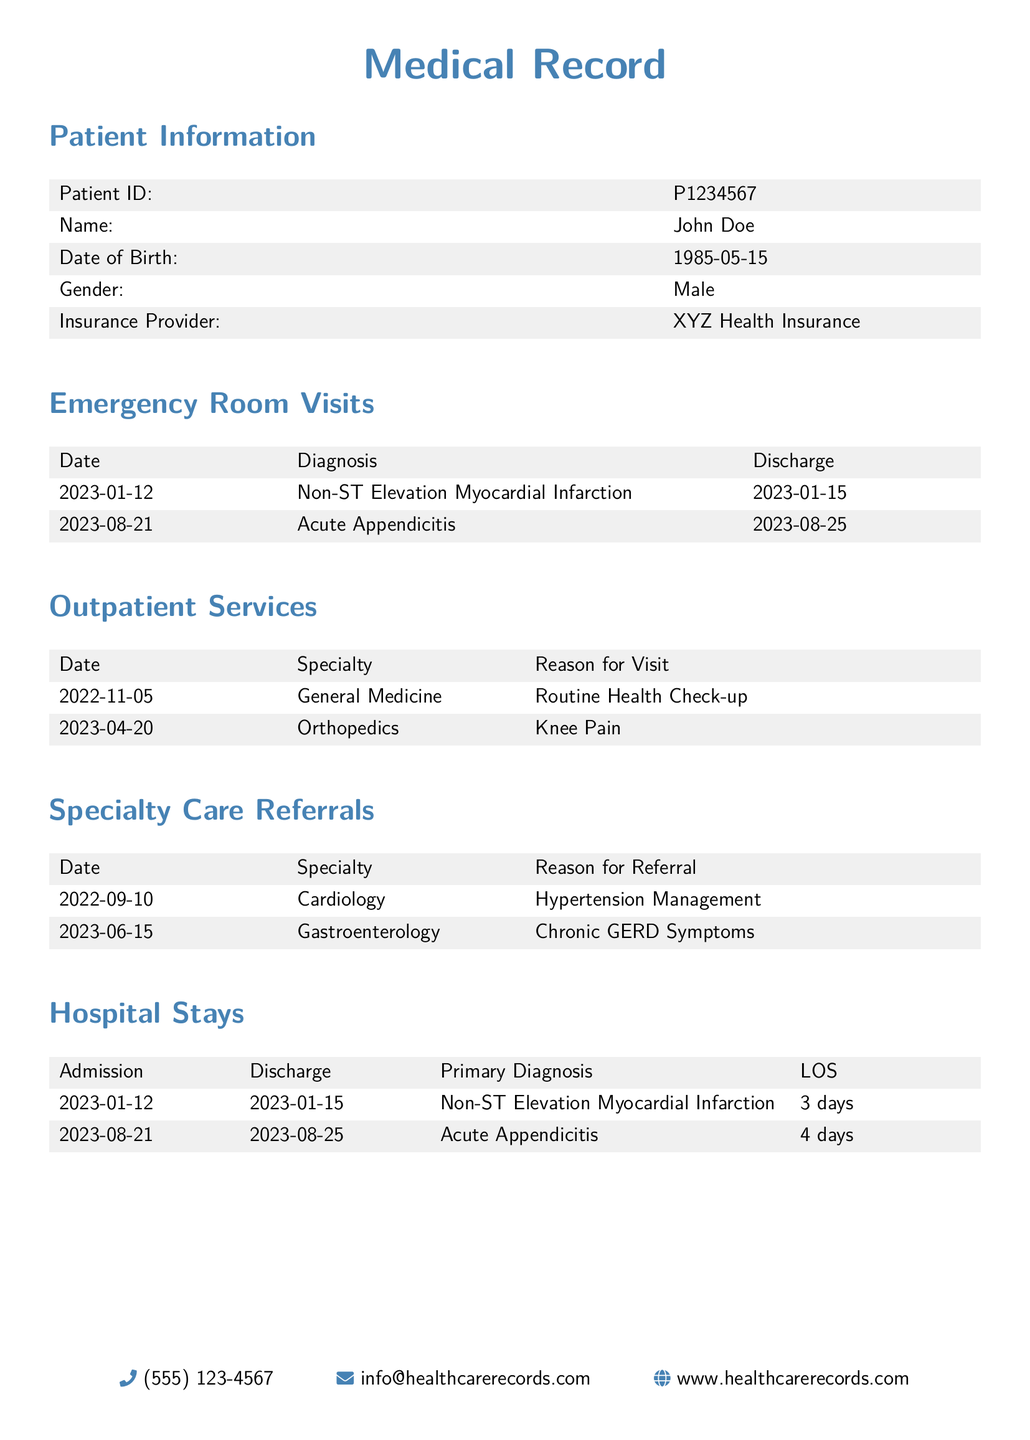What is the patient's name? The patient's name is listed in the Patient Information section of the document.
Answer: John Doe How many emergency room visits are recorded? The number of emergency room visits can be counted from the Emergency Room Visits section of the document.
Answer: 2 What was the primary diagnosis for the hospital stay on January 12, 2023? The primary diagnosis is found in the Hospital Stays section corresponding to the admission date.
Answer: Non-ST Elevation Myocardial Infarction What is the average length of stay for the hospital admissions listed? The average length of stay is calculated by averaging the LOS for all hospital stays shown in the document.
Answer: 3.5 days What specialty was consulted for the knee pain? The specialty for the knee pain visit is provided in the Outpatient Services section.
Answer: Orthopedics Which referral was made for chronic GERD symptoms? The referral for chronic GERD symptoms can be found in the Specialty Care Referrals section.
Answer: Gastroenterology What was the discharge date for the hospital stay on August 21, 2023? The discharge date is mentioned in the Hospital Stays section under the relevant admission.
Answer: 2023-08-25 When was the last outpatient service visit? The most recent outpatient service visit can be identified by checking the dates in the Outpatient Services section.
Answer: 2023-04-20 